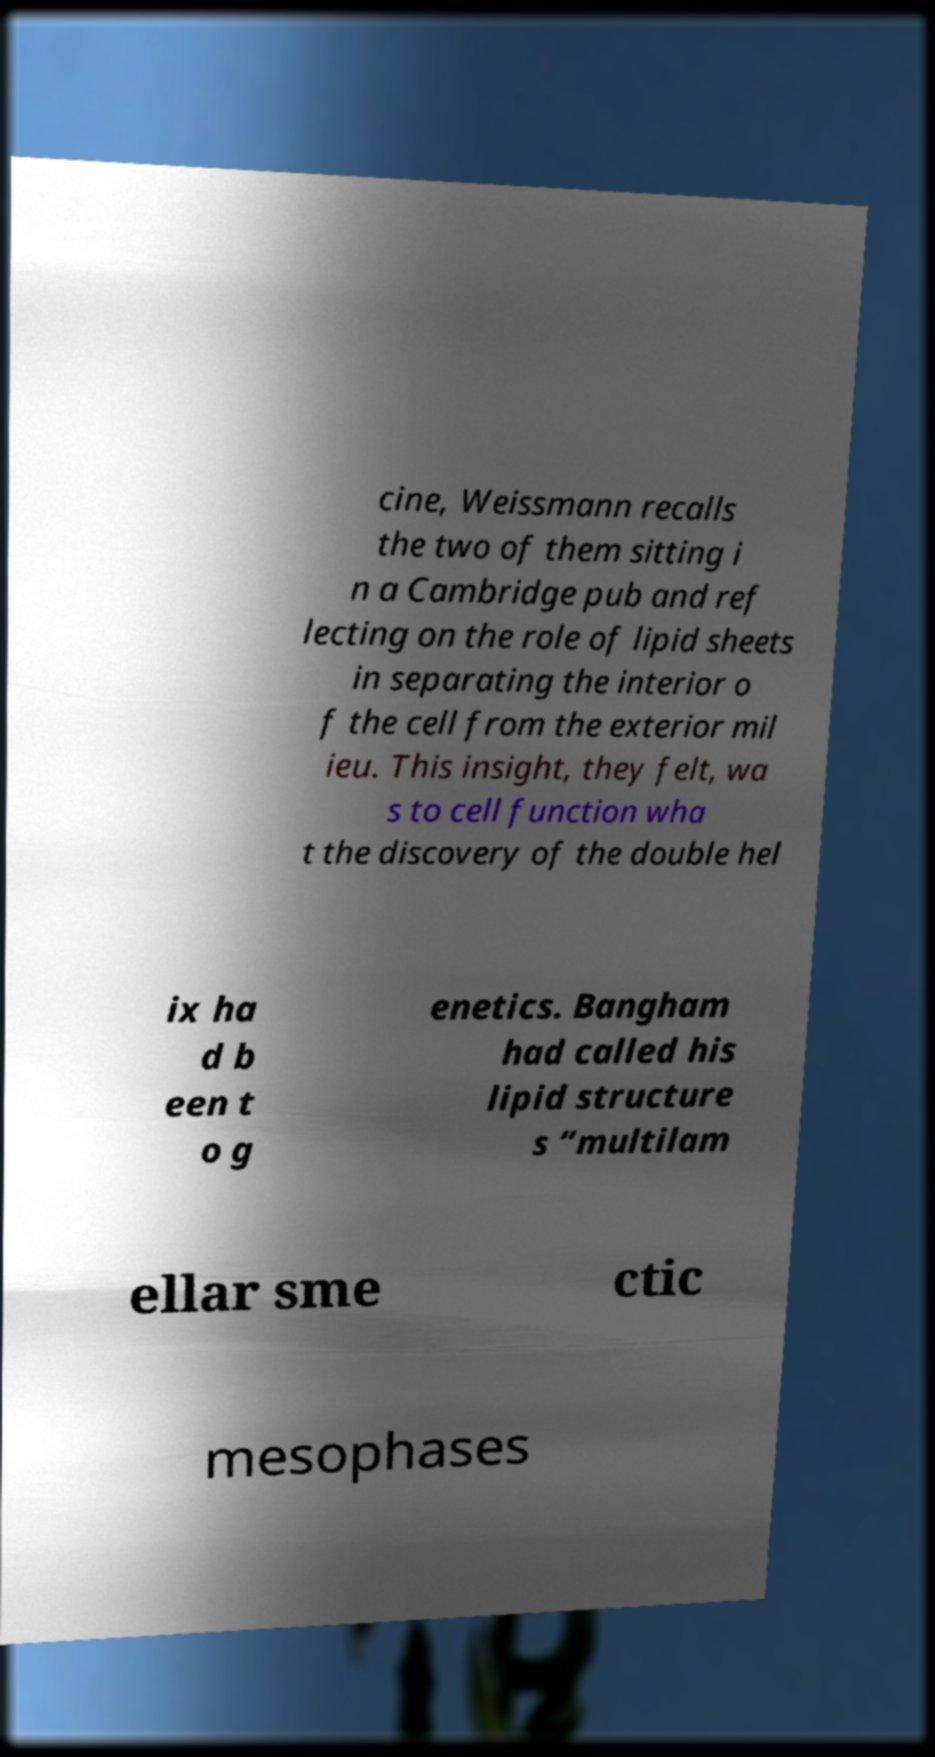Could you assist in decoding the text presented in this image and type it out clearly? cine, Weissmann recalls the two of them sitting i n a Cambridge pub and ref lecting on the role of lipid sheets in separating the interior o f the cell from the exterior mil ieu. This insight, they felt, wa s to cell function wha t the discovery of the double hel ix ha d b een t o g enetics. Bangham had called his lipid structure s “multilam ellar sme ctic mesophases 